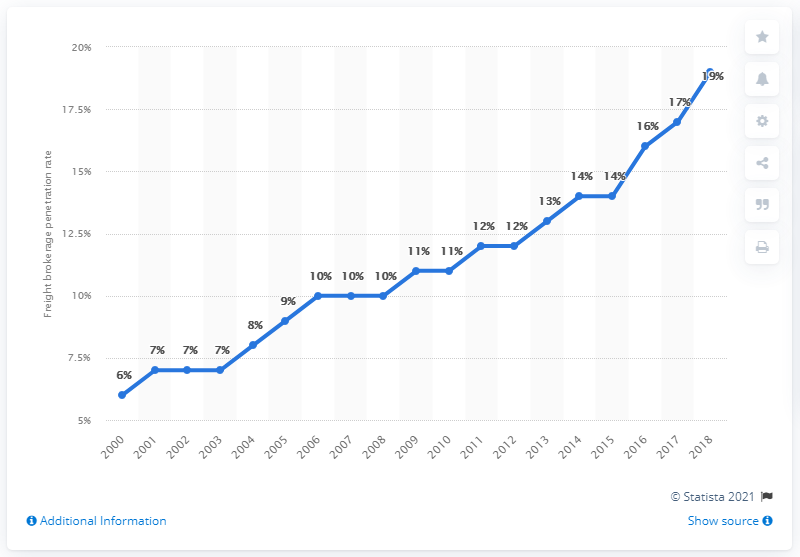Draw attention to some important aspects in this diagram. The freight brokerage penetration rate in the United States in 2018 was approximately 19%. The previous year's freight brokerage penetration rate was 17%. 